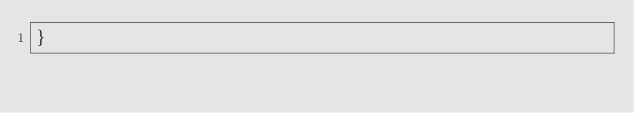<code> <loc_0><loc_0><loc_500><loc_500><_Go_>}
</code> 